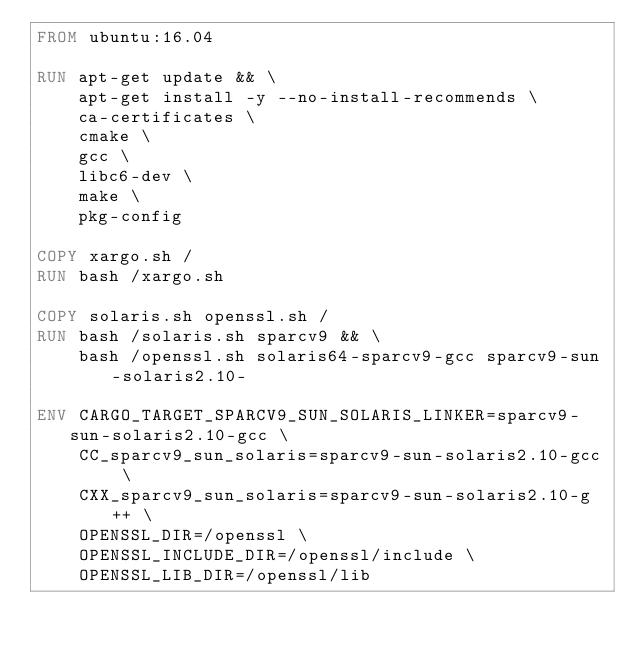<code> <loc_0><loc_0><loc_500><loc_500><_Dockerfile_>FROM ubuntu:16.04

RUN apt-get update && \
    apt-get install -y --no-install-recommends \
    ca-certificates \
    cmake \
    gcc \
    libc6-dev \
    make \
    pkg-config

COPY xargo.sh /
RUN bash /xargo.sh

COPY solaris.sh openssl.sh /
RUN bash /solaris.sh sparcv9 && \
    bash /openssl.sh solaris64-sparcv9-gcc sparcv9-sun-solaris2.10-

ENV CARGO_TARGET_SPARCV9_SUN_SOLARIS_LINKER=sparcv9-sun-solaris2.10-gcc \
    CC_sparcv9_sun_solaris=sparcv9-sun-solaris2.10-gcc \
    CXX_sparcv9_sun_solaris=sparcv9-sun-solaris2.10-g++ \
    OPENSSL_DIR=/openssl \
    OPENSSL_INCLUDE_DIR=/openssl/include \
    OPENSSL_LIB_DIR=/openssl/lib
</code> 